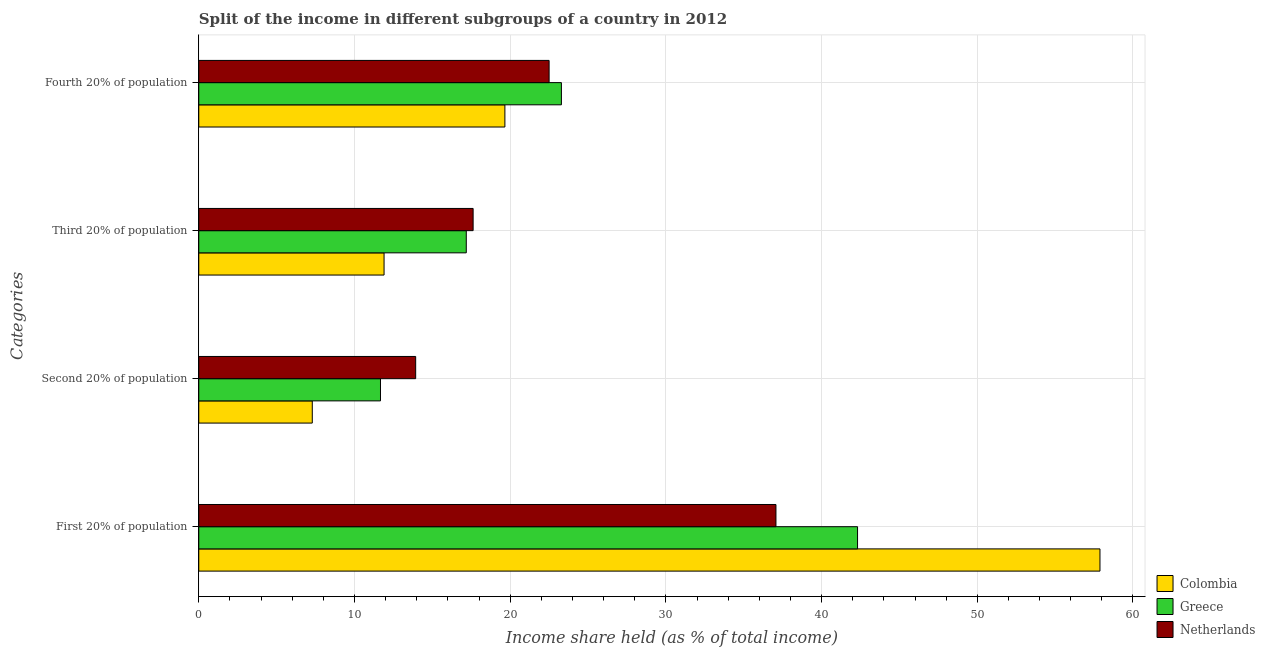How many groups of bars are there?
Provide a short and direct response. 4. Are the number of bars per tick equal to the number of legend labels?
Your answer should be compact. Yes. Are the number of bars on each tick of the Y-axis equal?
Give a very brief answer. Yes. How many bars are there on the 2nd tick from the bottom?
Ensure brevity in your answer.  3. What is the label of the 4th group of bars from the top?
Keep it short and to the point. First 20% of population. What is the share of the income held by fourth 20% of the population in Greece?
Offer a terse response. 23.29. Across all countries, what is the maximum share of the income held by second 20% of the population?
Keep it short and to the point. 13.93. Across all countries, what is the minimum share of the income held by third 20% of the population?
Offer a terse response. 11.9. What is the total share of the income held by first 20% of the population in the graph?
Your response must be concise. 137.26. What is the difference between the share of the income held by second 20% of the population in Greece and that in Netherlands?
Provide a succinct answer. -2.26. What is the difference between the share of the income held by first 20% of the population in Colombia and the share of the income held by fourth 20% of the population in Netherlands?
Make the answer very short. 35.38. What is the average share of the income held by first 20% of the population per country?
Provide a succinct answer. 45.75. What is the difference between the share of the income held by third 20% of the population and share of the income held by second 20% of the population in Netherlands?
Ensure brevity in your answer.  3.69. What is the ratio of the share of the income held by first 20% of the population in Colombia to that in Netherlands?
Ensure brevity in your answer.  1.56. What is the difference between the highest and the second highest share of the income held by second 20% of the population?
Ensure brevity in your answer.  2.26. What is the difference between the highest and the lowest share of the income held by fourth 20% of the population?
Provide a succinct answer. 3.63. Is the sum of the share of the income held by fourth 20% of the population in Netherlands and Greece greater than the maximum share of the income held by third 20% of the population across all countries?
Your response must be concise. Yes. Is it the case that in every country, the sum of the share of the income held by first 20% of the population and share of the income held by third 20% of the population is greater than the sum of share of the income held by fourth 20% of the population and share of the income held by second 20% of the population?
Offer a very short reply. Yes. How many bars are there?
Your answer should be compact. 12. Are all the bars in the graph horizontal?
Provide a short and direct response. Yes. Does the graph contain any zero values?
Give a very brief answer. No. Does the graph contain grids?
Provide a short and direct response. Yes. Where does the legend appear in the graph?
Keep it short and to the point. Bottom right. What is the title of the graph?
Offer a terse response. Split of the income in different subgroups of a country in 2012. What is the label or title of the X-axis?
Make the answer very short. Income share held (as % of total income). What is the label or title of the Y-axis?
Provide a short and direct response. Categories. What is the Income share held (as % of total income) of Colombia in First 20% of population?
Provide a short and direct response. 57.88. What is the Income share held (as % of total income) of Greece in First 20% of population?
Provide a succinct answer. 42.31. What is the Income share held (as % of total income) of Netherlands in First 20% of population?
Keep it short and to the point. 37.07. What is the Income share held (as % of total income) in Colombia in Second 20% of population?
Your answer should be very brief. 7.29. What is the Income share held (as % of total income) in Greece in Second 20% of population?
Offer a terse response. 11.67. What is the Income share held (as % of total income) in Netherlands in Second 20% of population?
Give a very brief answer. 13.93. What is the Income share held (as % of total income) of Colombia in Third 20% of population?
Your response must be concise. 11.9. What is the Income share held (as % of total income) in Greece in Third 20% of population?
Your answer should be very brief. 17.18. What is the Income share held (as % of total income) of Netherlands in Third 20% of population?
Provide a succinct answer. 17.62. What is the Income share held (as % of total income) in Colombia in Fourth 20% of population?
Your response must be concise. 19.66. What is the Income share held (as % of total income) of Greece in Fourth 20% of population?
Your response must be concise. 23.29. What is the Income share held (as % of total income) of Netherlands in Fourth 20% of population?
Give a very brief answer. 22.5. Across all Categories, what is the maximum Income share held (as % of total income) of Colombia?
Provide a succinct answer. 57.88. Across all Categories, what is the maximum Income share held (as % of total income) in Greece?
Offer a terse response. 42.31. Across all Categories, what is the maximum Income share held (as % of total income) of Netherlands?
Provide a short and direct response. 37.07. Across all Categories, what is the minimum Income share held (as % of total income) in Colombia?
Ensure brevity in your answer.  7.29. Across all Categories, what is the minimum Income share held (as % of total income) in Greece?
Your response must be concise. 11.67. Across all Categories, what is the minimum Income share held (as % of total income) of Netherlands?
Your answer should be compact. 13.93. What is the total Income share held (as % of total income) of Colombia in the graph?
Offer a very short reply. 96.73. What is the total Income share held (as % of total income) of Greece in the graph?
Provide a succinct answer. 94.45. What is the total Income share held (as % of total income) in Netherlands in the graph?
Give a very brief answer. 91.12. What is the difference between the Income share held (as % of total income) of Colombia in First 20% of population and that in Second 20% of population?
Ensure brevity in your answer.  50.59. What is the difference between the Income share held (as % of total income) of Greece in First 20% of population and that in Second 20% of population?
Keep it short and to the point. 30.64. What is the difference between the Income share held (as % of total income) in Netherlands in First 20% of population and that in Second 20% of population?
Keep it short and to the point. 23.14. What is the difference between the Income share held (as % of total income) in Colombia in First 20% of population and that in Third 20% of population?
Ensure brevity in your answer.  45.98. What is the difference between the Income share held (as % of total income) of Greece in First 20% of population and that in Third 20% of population?
Give a very brief answer. 25.13. What is the difference between the Income share held (as % of total income) in Netherlands in First 20% of population and that in Third 20% of population?
Make the answer very short. 19.45. What is the difference between the Income share held (as % of total income) in Colombia in First 20% of population and that in Fourth 20% of population?
Keep it short and to the point. 38.22. What is the difference between the Income share held (as % of total income) of Greece in First 20% of population and that in Fourth 20% of population?
Your response must be concise. 19.02. What is the difference between the Income share held (as % of total income) of Netherlands in First 20% of population and that in Fourth 20% of population?
Offer a terse response. 14.57. What is the difference between the Income share held (as % of total income) of Colombia in Second 20% of population and that in Third 20% of population?
Give a very brief answer. -4.61. What is the difference between the Income share held (as % of total income) in Greece in Second 20% of population and that in Third 20% of population?
Offer a terse response. -5.51. What is the difference between the Income share held (as % of total income) in Netherlands in Second 20% of population and that in Third 20% of population?
Your response must be concise. -3.69. What is the difference between the Income share held (as % of total income) in Colombia in Second 20% of population and that in Fourth 20% of population?
Make the answer very short. -12.37. What is the difference between the Income share held (as % of total income) in Greece in Second 20% of population and that in Fourth 20% of population?
Offer a very short reply. -11.62. What is the difference between the Income share held (as % of total income) in Netherlands in Second 20% of population and that in Fourth 20% of population?
Provide a succinct answer. -8.57. What is the difference between the Income share held (as % of total income) of Colombia in Third 20% of population and that in Fourth 20% of population?
Ensure brevity in your answer.  -7.76. What is the difference between the Income share held (as % of total income) of Greece in Third 20% of population and that in Fourth 20% of population?
Offer a very short reply. -6.11. What is the difference between the Income share held (as % of total income) in Netherlands in Third 20% of population and that in Fourth 20% of population?
Make the answer very short. -4.88. What is the difference between the Income share held (as % of total income) in Colombia in First 20% of population and the Income share held (as % of total income) in Greece in Second 20% of population?
Keep it short and to the point. 46.21. What is the difference between the Income share held (as % of total income) in Colombia in First 20% of population and the Income share held (as % of total income) in Netherlands in Second 20% of population?
Ensure brevity in your answer.  43.95. What is the difference between the Income share held (as % of total income) in Greece in First 20% of population and the Income share held (as % of total income) in Netherlands in Second 20% of population?
Ensure brevity in your answer.  28.38. What is the difference between the Income share held (as % of total income) in Colombia in First 20% of population and the Income share held (as % of total income) in Greece in Third 20% of population?
Offer a terse response. 40.7. What is the difference between the Income share held (as % of total income) of Colombia in First 20% of population and the Income share held (as % of total income) of Netherlands in Third 20% of population?
Keep it short and to the point. 40.26. What is the difference between the Income share held (as % of total income) of Greece in First 20% of population and the Income share held (as % of total income) of Netherlands in Third 20% of population?
Offer a terse response. 24.69. What is the difference between the Income share held (as % of total income) in Colombia in First 20% of population and the Income share held (as % of total income) in Greece in Fourth 20% of population?
Offer a terse response. 34.59. What is the difference between the Income share held (as % of total income) of Colombia in First 20% of population and the Income share held (as % of total income) of Netherlands in Fourth 20% of population?
Ensure brevity in your answer.  35.38. What is the difference between the Income share held (as % of total income) of Greece in First 20% of population and the Income share held (as % of total income) of Netherlands in Fourth 20% of population?
Give a very brief answer. 19.81. What is the difference between the Income share held (as % of total income) in Colombia in Second 20% of population and the Income share held (as % of total income) in Greece in Third 20% of population?
Provide a succinct answer. -9.89. What is the difference between the Income share held (as % of total income) of Colombia in Second 20% of population and the Income share held (as % of total income) of Netherlands in Third 20% of population?
Make the answer very short. -10.33. What is the difference between the Income share held (as % of total income) in Greece in Second 20% of population and the Income share held (as % of total income) in Netherlands in Third 20% of population?
Your answer should be very brief. -5.95. What is the difference between the Income share held (as % of total income) in Colombia in Second 20% of population and the Income share held (as % of total income) in Greece in Fourth 20% of population?
Your answer should be compact. -16. What is the difference between the Income share held (as % of total income) of Colombia in Second 20% of population and the Income share held (as % of total income) of Netherlands in Fourth 20% of population?
Provide a succinct answer. -15.21. What is the difference between the Income share held (as % of total income) of Greece in Second 20% of population and the Income share held (as % of total income) of Netherlands in Fourth 20% of population?
Offer a terse response. -10.83. What is the difference between the Income share held (as % of total income) in Colombia in Third 20% of population and the Income share held (as % of total income) in Greece in Fourth 20% of population?
Offer a terse response. -11.39. What is the difference between the Income share held (as % of total income) of Colombia in Third 20% of population and the Income share held (as % of total income) of Netherlands in Fourth 20% of population?
Your response must be concise. -10.6. What is the difference between the Income share held (as % of total income) in Greece in Third 20% of population and the Income share held (as % of total income) in Netherlands in Fourth 20% of population?
Give a very brief answer. -5.32. What is the average Income share held (as % of total income) in Colombia per Categories?
Provide a short and direct response. 24.18. What is the average Income share held (as % of total income) of Greece per Categories?
Your answer should be compact. 23.61. What is the average Income share held (as % of total income) of Netherlands per Categories?
Give a very brief answer. 22.78. What is the difference between the Income share held (as % of total income) in Colombia and Income share held (as % of total income) in Greece in First 20% of population?
Give a very brief answer. 15.57. What is the difference between the Income share held (as % of total income) of Colombia and Income share held (as % of total income) of Netherlands in First 20% of population?
Your answer should be compact. 20.81. What is the difference between the Income share held (as % of total income) of Greece and Income share held (as % of total income) of Netherlands in First 20% of population?
Provide a succinct answer. 5.24. What is the difference between the Income share held (as % of total income) of Colombia and Income share held (as % of total income) of Greece in Second 20% of population?
Give a very brief answer. -4.38. What is the difference between the Income share held (as % of total income) in Colombia and Income share held (as % of total income) in Netherlands in Second 20% of population?
Give a very brief answer. -6.64. What is the difference between the Income share held (as % of total income) of Greece and Income share held (as % of total income) of Netherlands in Second 20% of population?
Provide a short and direct response. -2.26. What is the difference between the Income share held (as % of total income) in Colombia and Income share held (as % of total income) in Greece in Third 20% of population?
Keep it short and to the point. -5.28. What is the difference between the Income share held (as % of total income) of Colombia and Income share held (as % of total income) of Netherlands in Third 20% of population?
Give a very brief answer. -5.72. What is the difference between the Income share held (as % of total income) in Greece and Income share held (as % of total income) in Netherlands in Third 20% of population?
Offer a terse response. -0.44. What is the difference between the Income share held (as % of total income) of Colombia and Income share held (as % of total income) of Greece in Fourth 20% of population?
Offer a very short reply. -3.63. What is the difference between the Income share held (as % of total income) in Colombia and Income share held (as % of total income) in Netherlands in Fourth 20% of population?
Your answer should be very brief. -2.84. What is the difference between the Income share held (as % of total income) of Greece and Income share held (as % of total income) of Netherlands in Fourth 20% of population?
Provide a succinct answer. 0.79. What is the ratio of the Income share held (as % of total income) in Colombia in First 20% of population to that in Second 20% of population?
Provide a short and direct response. 7.94. What is the ratio of the Income share held (as % of total income) of Greece in First 20% of population to that in Second 20% of population?
Offer a very short reply. 3.63. What is the ratio of the Income share held (as % of total income) of Netherlands in First 20% of population to that in Second 20% of population?
Your answer should be compact. 2.66. What is the ratio of the Income share held (as % of total income) in Colombia in First 20% of population to that in Third 20% of population?
Offer a terse response. 4.86. What is the ratio of the Income share held (as % of total income) in Greece in First 20% of population to that in Third 20% of population?
Ensure brevity in your answer.  2.46. What is the ratio of the Income share held (as % of total income) in Netherlands in First 20% of population to that in Third 20% of population?
Offer a terse response. 2.1. What is the ratio of the Income share held (as % of total income) of Colombia in First 20% of population to that in Fourth 20% of population?
Offer a terse response. 2.94. What is the ratio of the Income share held (as % of total income) of Greece in First 20% of population to that in Fourth 20% of population?
Ensure brevity in your answer.  1.82. What is the ratio of the Income share held (as % of total income) in Netherlands in First 20% of population to that in Fourth 20% of population?
Provide a short and direct response. 1.65. What is the ratio of the Income share held (as % of total income) of Colombia in Second 20% of population to that in Third 20% of population?
Your response must be concise. 0.61. What is the ratio of the Income share held (as % of total income) in Greece in Second 20% of population to that in Third 20% of population?
Give a very brief answer. 0.68. What is the ratio of the Income share held (as % of total income) in Netherlands in Second 20% of population to that in Third 20% of population?
Ensure brevity in your answer.  0.79. What is the ratio of the Income share held (as % of total income) of Colombia in Second 20% of population to that in Fourth 20% of population?
Give a very brief answer. 0.37. What is the ratio of the Income share held (as % of total income) of Greece in Second 20% of population to that in Fourth 20% of population?
Keep it short and to the point. 0.5. What is the ratio of the Income share held (as % of total income) of Netherlands in Second 20% of population to that in Fourth 20% of population?
Provide a succinct answer. 0.62. What is the ratio of the Income share held (as % of total income) in Colombia in Third 20% of population to that in Fourth 20% of population?
Make the answer very short. 0.61. What is the ratio of the Income share held (as % of total income) in Greece in Third 20% of population to that in Fourth 20% of population?
Your answer should be compact. 0.74. What is the ratio of the Income share held (as % of total income) of Netherlands in Third 20% of population to that in Fourth 20% of population?
Offer a terse response. 0.78. What is the difference between the highest and the second highest Income share held (as % of total income) of Colombia?
Provide a succinct answer. 38.22. What is the difference between the highest and the second highest Income share held (as % of total income) in Greece?
Make the answer very short. 19.02. What is the difference between the highest and the second highest Income share held (as % of total income) in Netherlands?
Ensure brevity in your answer.  14.57. What is the difference between the highest and the lowest Income share held (as % of total income) of Colombia?
Keep it short and to the point. 50.59. What is the difference between the highest and the lowest Income share held (as % of total income) of Greece?
Offer a terse response. 30.64. What is the difference between the highest and the lowest Income share held (as % of total income) of Netherlands?
Your response must be concise. 23.14. 